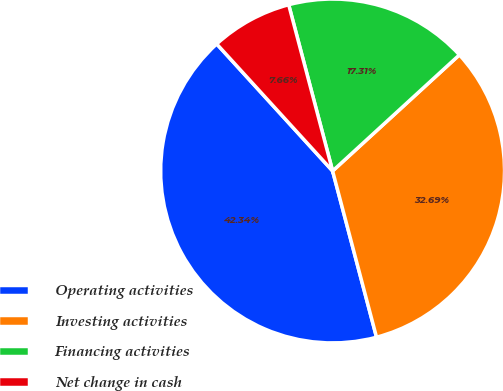Convert chart. <chart><loc_0><loc_0><loc_500><loc_500><pie_chart><fcel>Operating activities<fcel>Investing activities<fcel>Financing activities<fcel>Net change in cash<nl><fcel>42.34%<fcel>32.69%<fcel>17.31%<fcel>7.66%<nl></chart> 